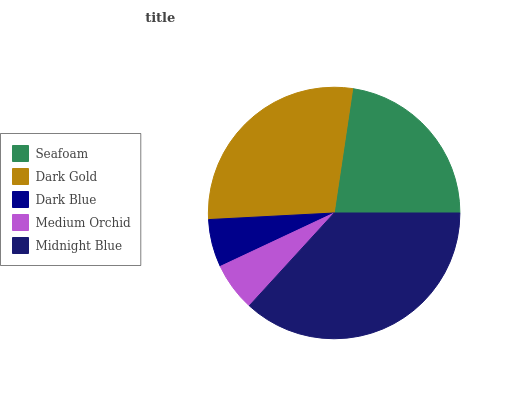Is Dark Blue the minimum?
Answer yes or no. Yes. Is Midnight Blue the maximum?
Answer yes or no. Yes. Is Dark Gold the minimum?
Answer yes or no. No. Is Dark Gold the maximum?
Answer yes or no. No. Is Dark Gold greater than Seafoam?
Answer yes or no. Yes. Is Seafoam less than Dark Gold?
Answer yes or no. Yes. Is Seafoam greater than Dark Gold?
Answer yes or no. No. Is Dark Gold less than Seafoam?
Answer yes or no. No. Is Seafoam the high median?
Answer yes or no. Yes. Is Seafoam the low median?
Answer yes or no. Yes. Is Dark Blue the high median?
Answer yes or no. No. Is Dark Blue the low median?
Answer yes or no. No. 